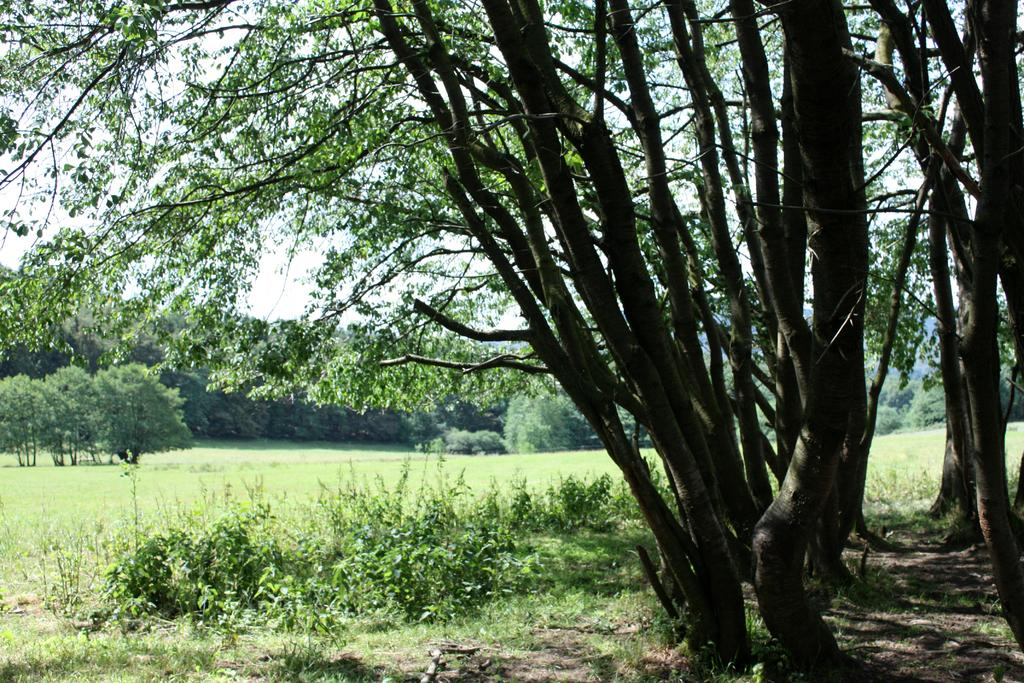What type of natural elements can be seen in the image? There are trees and plants visible in the image. What is the surface on which the trees and plants are growing? The ground is visible in the image. What else can be seen in the sky in the image? The sky is visible in the image. What type of basin is used to hold the oatmeal in the image? There is no basin or oatmeal present in the image. What is covering the trees in the image? There is no cover or object covering the trees in the image. 